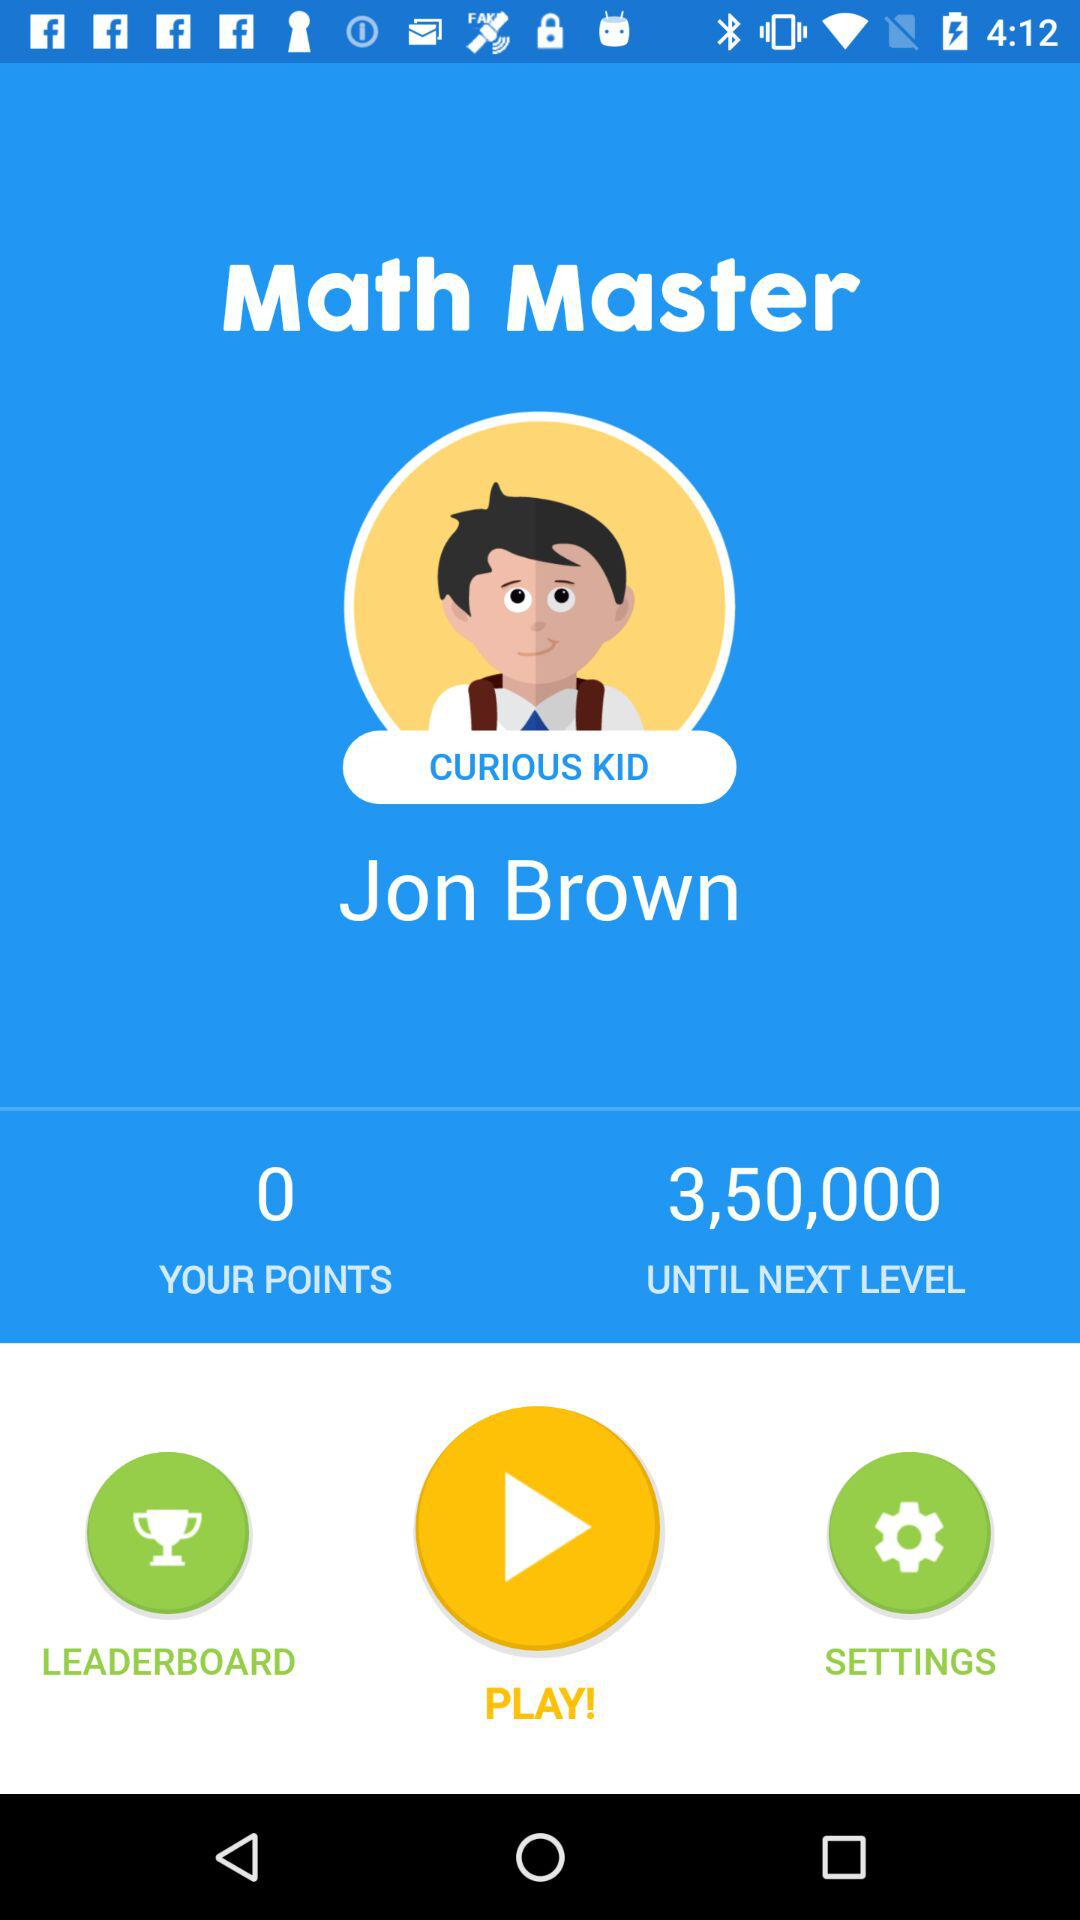What is the name of the person? The name of the person is Jon Brown. 